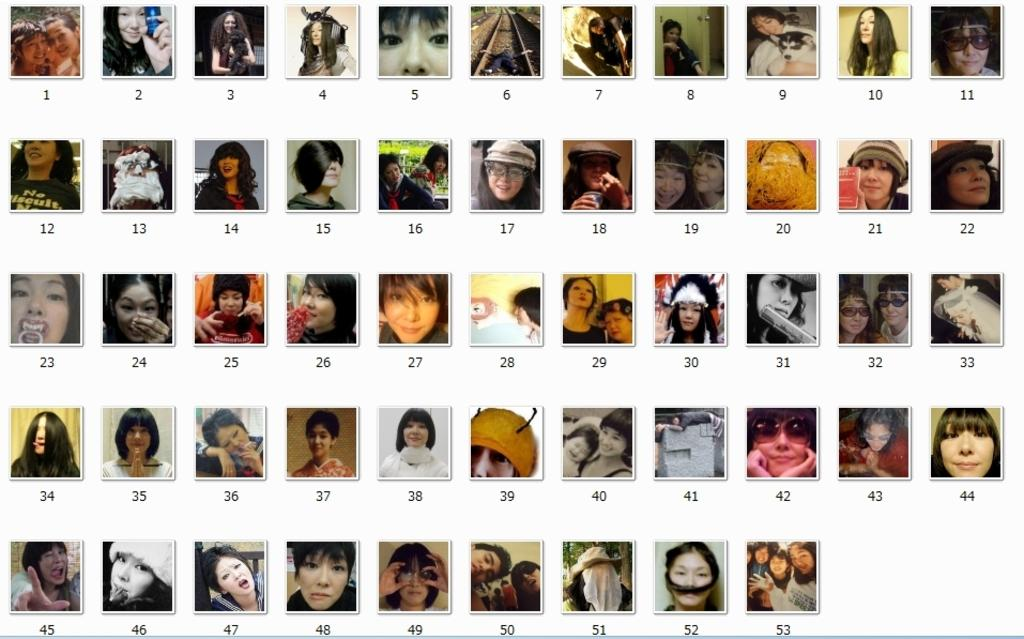What is the main subject of the image? The main subject of the image is multiple images of women. Can you describe the facial expressions of the women in the images? Each woman in the images has a different facial expression. What type of bells can be heard ringing in the image? There are no bells present in the image, and therefore no such sound can be heard. What type of cherry is being eaten by one of the women in the image? There is no cherry present in the image, and therefore no such food can be seen. 